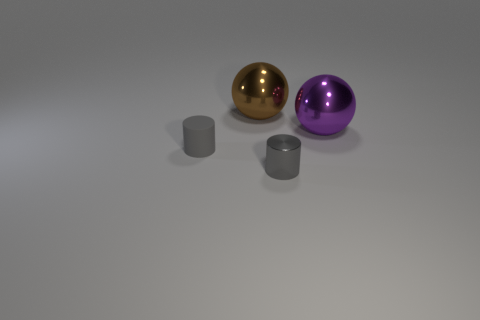Subtract all purple balls. How many balls are left? 1 Subtract 0 cyan balls. How many objects are left? 4 Subtract 1 cylinders. How many cylinders are left? 1 Subtract all purple cylinders. Subtract all purple spheres. How many cylinders are left? 2 Subtract all red blocks. How many purple spheres are left? 1 Subtract all big things. Subtract all large shiny balls. How many objects are left? 0 Add 3 large metal objects. How many large metal objects are left? 5 Add 3 large matte cubes. How many large matte cubes exist? 3 Add 3 tiny gray cylinders. How many objects exist? 7 